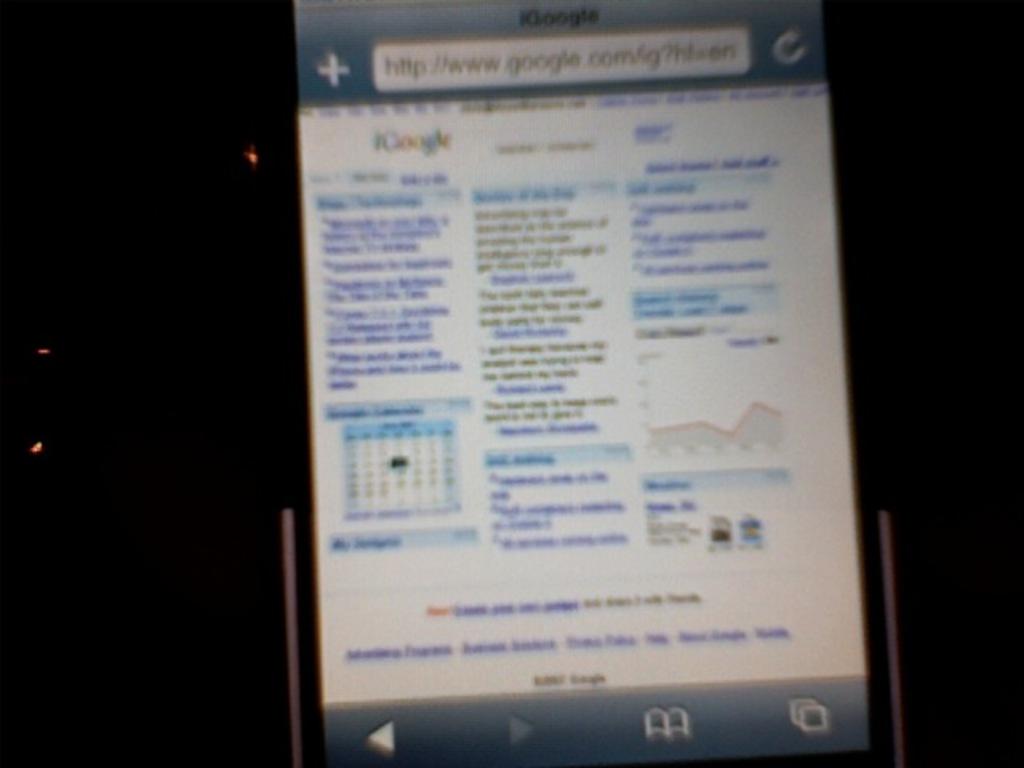What search engine is this person using?
Make the answer very short. Google. 